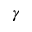<formula> <loc_0><loc_0><loc_500><loc_500>\gamma</formula> 